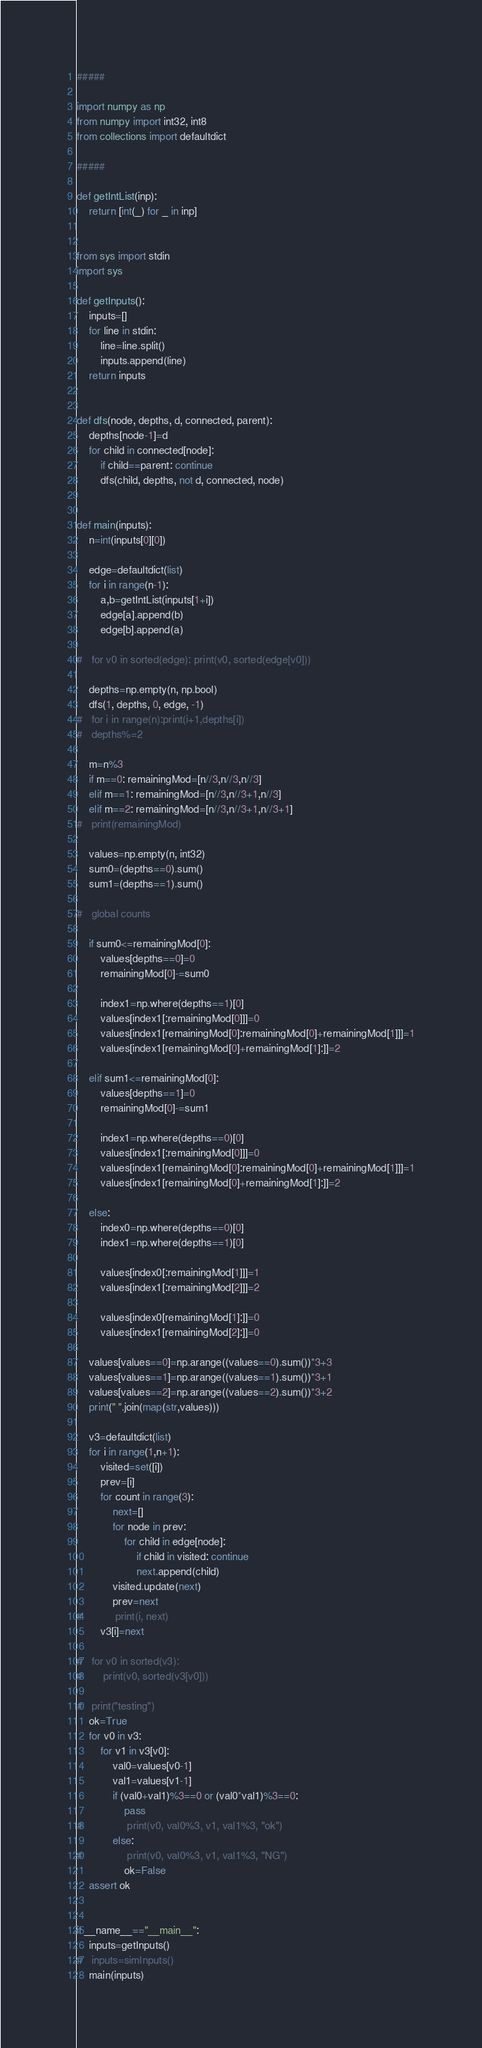Convert code to text. <code><loc_0><loc_0><loc_500><loc_500><_Python_>
#####

import numpy as np
from numpy import int32, int8
from collections import defaultdict

#####

def getIntList(inp):
	return [int(_) for _ in inp]


from sys import stdin
import sys

def getInputs():
	inputs=[]
	for line in stdin:
		line=line.split()
		inputs.append(line)
	return inputs


def dfs(node, depths, d, connected, parent):
	depths[node-1]=d
	for child in connected[node]:
		if child==parent: continue
		dfs(child, depths, not d, connected, node)
		

def main(inputs):
	n=int(inputs[0][0])
	
	edge=defaultdict(list)
	for i in range(n-1):
		a,b=getIntList(inputs[1+i])
		edge[a].append(b)
		edge[b].append(a)
	
# 	for v0 in sorted(edge): print(v0, sorted(edge[v0]))
	
	depths=np.empty(n, np.bool)
	dfs(1, depths, 0, edge, -1)
# 	for i in range(n):print(i+1,depths[i])
# 	depths%=2
	
	m=n%3
	if m==0: remainingMod=[n//3,n//3,n//3]
	elif m==1: remainingMod=[n//3,n//3+1,n//3]
	elif m==2: remainingMod=[n//3,n//3+1,n//3+1]
# 	print(remainingMod)
	
	values=np.empty(n, int32)
	sum0=(depths==0).sum()
	sum1=(depths==1).sum()
	
# 	global counts
	
	if sum0<=remainingMod[0]:
		values[depths==0]=0
		remainingMod[0]-=sum0
		
		index1=np.where(depths==1)[0]
		values[index1[:remainingMod[0]]]=0
		values[index1[remainingMod[0]:remainingMod[0]+remainingMod[1]]]=1
		values[index1[remainingMod[0]+remainingMod[1]:]]=2

	elif sum1<=remainingMod[0]:
		values[depths==1]=0
		remainingMod[0]-=sum1
		
		index1=np.where(depths==0)[0]
		values[index1[:remainingMod[0]]]=0
		values[index1[remainingMod[0]:remainingMod[0]+remainingMod[1]]]=1
		values[index1[remainingMod[0]+remainingMod[1]:]]=2
		
	else:
		index0=np.where(depths==0)[0]
		index1=np.where(depths==1)[0]
		
		values[index0[:remainingMod[1]]]=1
		values[index1[:remainingMod[2]]]=2
		
		values[index0[remainingMod[1]:]]=0
		values[index1[remainingMod[2]:]]=0
	
	values[values==0]=np.arange((values==0).sum())*3+3
	values[values==1]=np.arange((values==1).sum())*3+1
	values[values==2]=np.arange((values==2).sum())*3+2
	print(" ".join(map(str,values)))
	
	v3=defaultdict(list)
	for i in range(1,n+1):
		visited=set([i])
		prev=[i]
		for count in range(3):
			next=[]
			for node in prev:
				for child in edge[node]:
					if child in visited: continue
					next.append(child)
			visited.update(next)
			prev=next
# 			print(i, next)
		v3[i]=next
	
# 	for v0 in sorted(v3):
# 		print(v0, sorted(v3[v0]))
	
# 	print("testing")
	ok=True
	for v0 in v3:
		for v1 in v3[v0]:
			val0=values[v0-1]
			val1=values[v1-1]
			if (val0+val1)%3==0 or (val0*val1)%3==0:
				pass
# 				print(v0, val0%3, v1, val1%3, "ok")
			else:
# 				print(v0, val0%3, v1, val1%3, "NG")
				ok=False
	assert ok


if __name__=="__main__":
	inputs=getInputs()
# 	inputs=simInputs()
	main(inputs)
</code> 